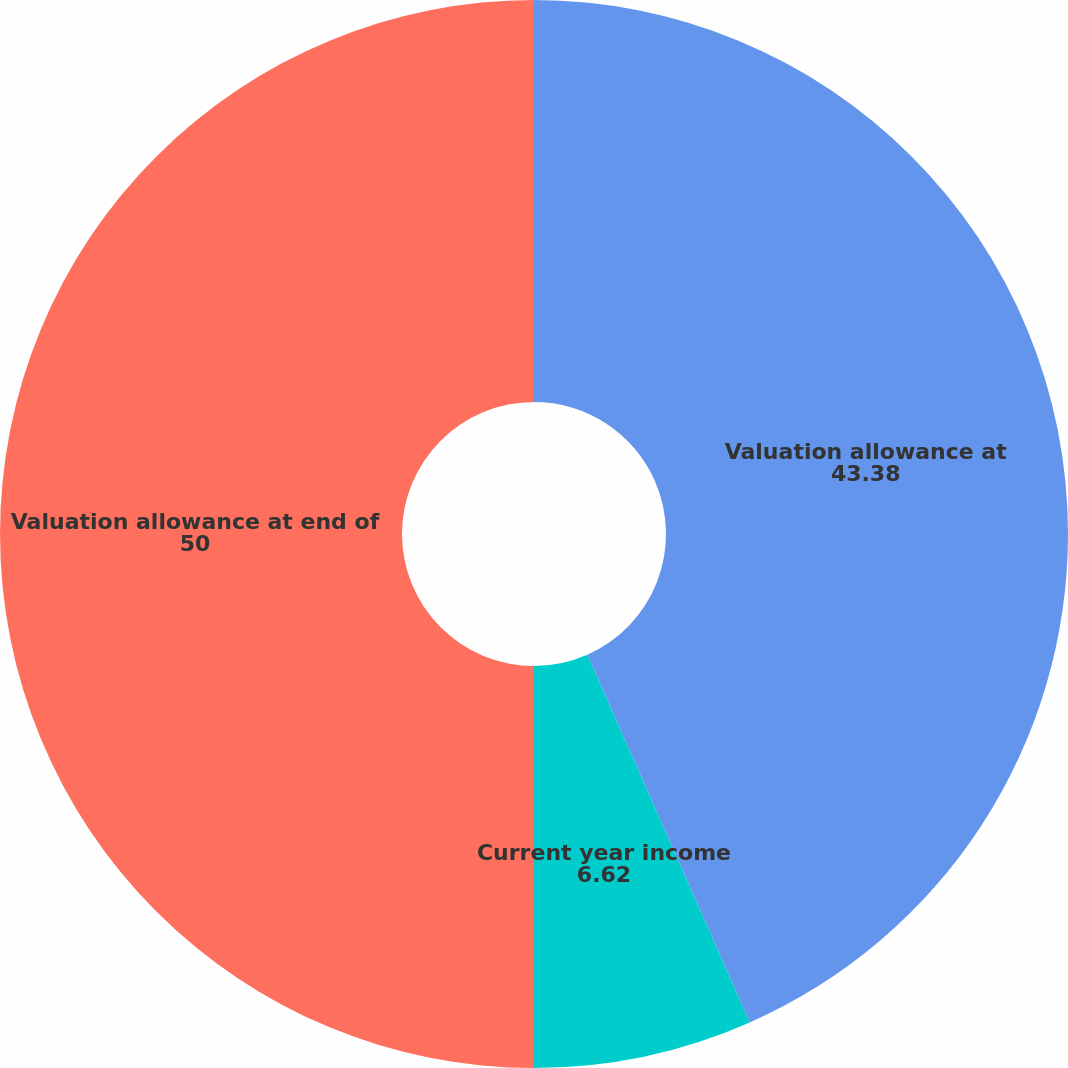Convert chart. <chart><loc_0><loc_0><loc_500><loc_500><pie_chart><fcel>Valuation allowance at<fcel>Current year income<fcel>Valuation allowance at end of<nl><fcel>43.38%<fcel>6.62%<fcel>50.0%<nl></chart> 